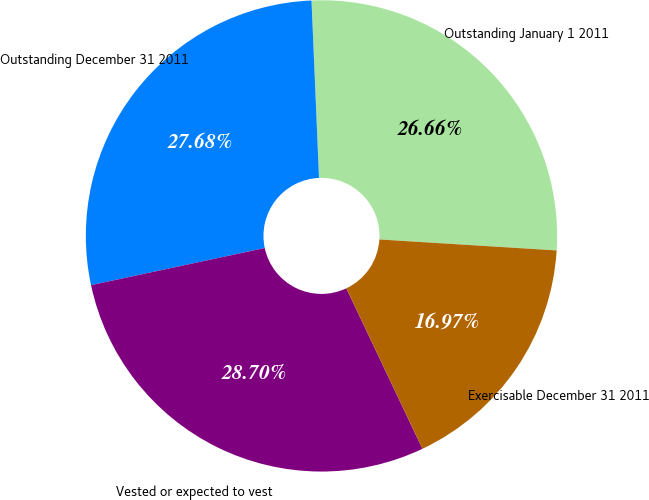Convert chart. <chart><loc_0><loc_0><loc_500><loc_500><pie_chart><fcel>Outstanding January 1 2011<fcel>Outstanding December 31 2011<fcel>Vested or expected to vest<fcel>Exercisable December 31 2011<nl><fcel>26.66%<fcel>27.68%<fcel>28.7%<fcel>16.97%<nl></chart> 